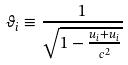<formula> <loc_0><loc_0><loc_500><loc_500>\vartheta _ { i } \equiv \frac { 1 } { \sqrt { 1 - \frac { u _ { i } + u _ { i } } { c ^ { 2 } } } }</formula> 